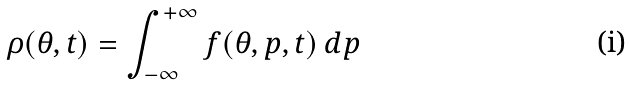<formula> <loc_0><loc_0><loc_500><loc_500>\rho ( \theta , t ) = \int _ { - \infty } ^ { + \infty } f ( \theta , p , t ) \, d p</formula> 